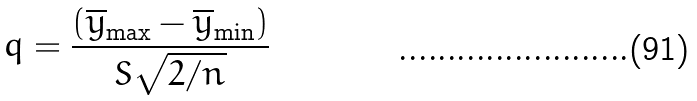<formula> <loc_0><loc_0><loc_500><loc_500>q = \frac { ( \overline { y } _ { \max } - \overline { y } _ { \min } ) } { S \sqrt { 2 / n } }</formula> 